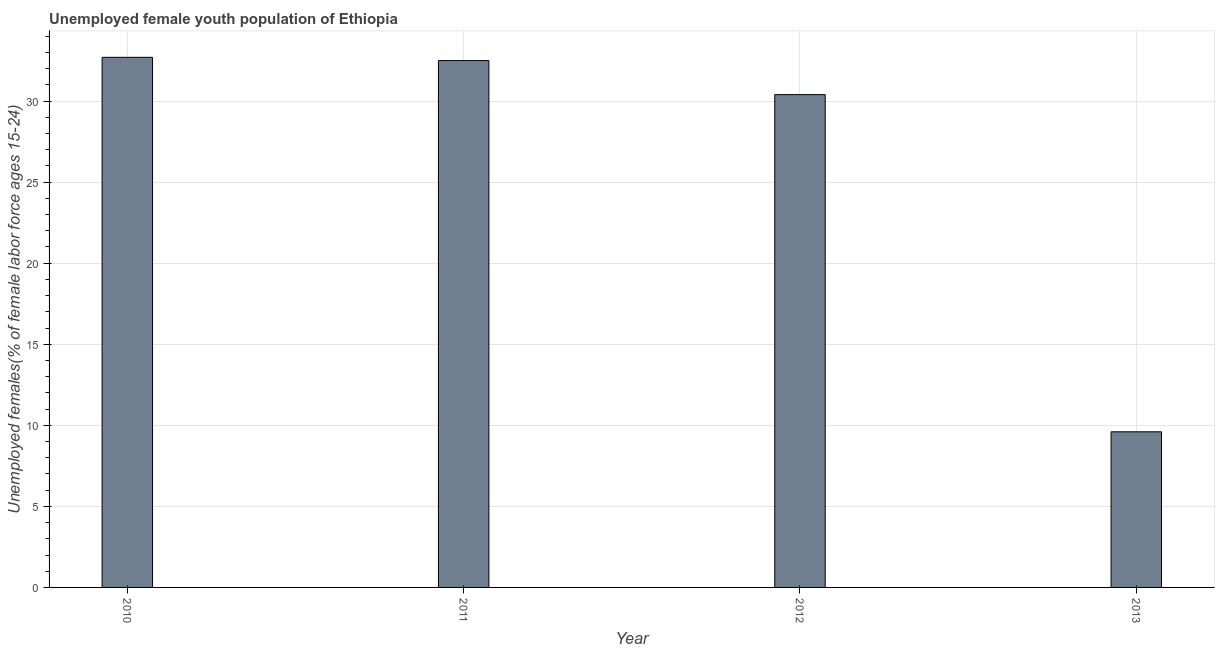What is the title of the graph?
Keep it short and to the point. Unemployed female youth population of Ethiopia. What is the label or title of the Y-axis?
Ensure brevity in your answer.  Unemployed females(% of female labor force ages 15-24). What is the unemployed female youth in 2010?
Your answer should be very brief. 32.7. Across all years, what is the maximum unemployed female youth?
Your answer should be compact. 32.7. Across all years, what is the minimum unemployed female youth?
Provide a succinct answer. 9.6. In which year was the unemployed female youth minimum?
Ensure brevity in your answer.  2013. What is the sum of the unemployed female youth?
Your answer should be compact. 105.2. What is the difference between the unemployed female youth in 2010 and 2011?
Offer a terse response. 0.2. What is the average unemployed female youth per year?
Keep it short and to the point. 26.3. What is the median unemployed female youth?
Keep it short and to the point. 31.45. Do a majority of the years between 2013 and 2012 (inclusive) have unemployed female youth greater than 24 %?
Make the answer very short. No. What is the ratio of the unemployed female youth in 2010 to that in 2012?
Ensure brevity in your answer.  1.08. Is the difference between the unemployed female youth in 2011 and 2013 greater than the difference between any two years?
Your answer should be compact. No. What is the difference between the highest and the second highest unemployed female youth?
Offer a terse response. 0.2. What is the difference between the highest and the lowest unemployed female youth?
Your answer should be very brief. 23.1. How many bars are there?
Your answer should be very brief. 4. What is the difference between two consecutive major ticks on the Y-axis?
Your answer should be very brief. 5. Are the values on the major ticks of Y-axis written in scientific E-notation?
Make the answer very short. No. What is the Unemployed females(% of female labor force ages 15-24) of 2010?
Your answer should be compact. 32.7. What is the Unemployed females(% of female labor force ages 15-24) of 2011?
Ensure brevity in your answer.  32.5. What is the Unemployed females(% of female labor force ages 15-24) in 2012?
Offer a very short reply. 30.4. What is the Unemployed females(% of female labor force ages 15-24) of 2013?
Make the answer very short. 9.6. What is the difference between the Unemployed females(% of female labor force ages 15-24) in 2010 and 2011?
Provide a succinct answer. 0.2. What is the difference between the Unemployed females(% of female labor force ages 15-24) in 2010 and 2012?
Make the answer very short. 2.3. What is the difference between the Unemployed females(% of female labor force ages 15-24) in 2010 and 2013?
Provide a succinct answer. 23.1. What is the difference between the Unemployed females(% of female labor force ages 15-24) in 2011 and 2012?
Your answer should be compact. 2.1. What is the difference between the Unemployed females(% of female labor force ages 15-24) in 2011 and 2013?
Make the answer very short. 22.9. What is the difference between the Unemployed females(% of female labor force ages 15-24) in 2012 and 2013?
Your answer should be compact. 20.8. What is the ratio of the Unemployed females(% of female labor force ages 15-24) in 2010 to that in 2012?
Offer a terse response. 1.08. What is the ratio of the Unemployed females(% of female labor force ages 15-24) in 2010 to that in 2013?
Your answer should be very brief. 3.41. What is the ratio of the Unemployed females(% of female labor force ages 15-24) in 2011 to that in 2012?
Offer a terse response. 1.07. What is the ratio of the Unemployed females(% of female labor force ages 15-24) in 2011 to that in 2013?
Offer a very short reply. 3.38. What is the ratio of the Unemployed females(% of female labor force ages 15-24) in 2012 to that in 2013?
Offer a terse response. 3.17. 